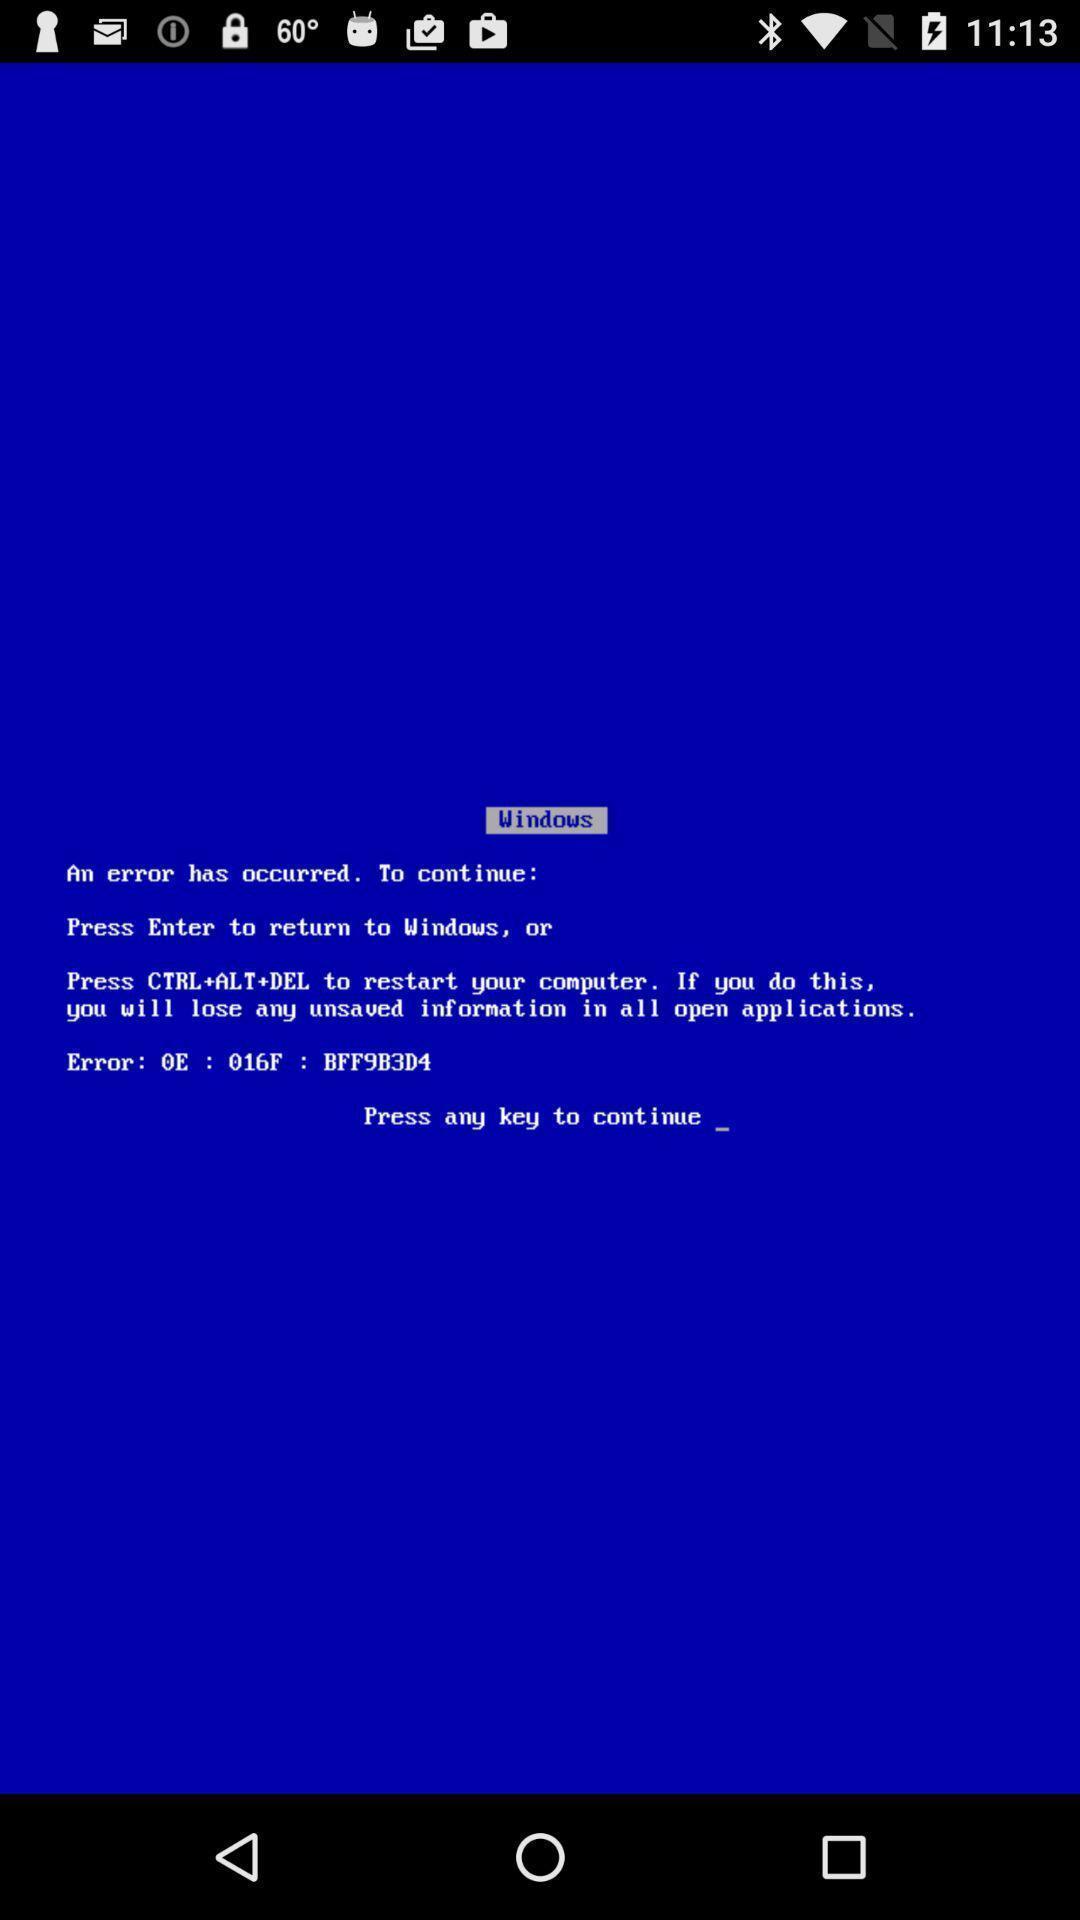Tell me what you see in this picture. Screen shows error occurred in a page. 